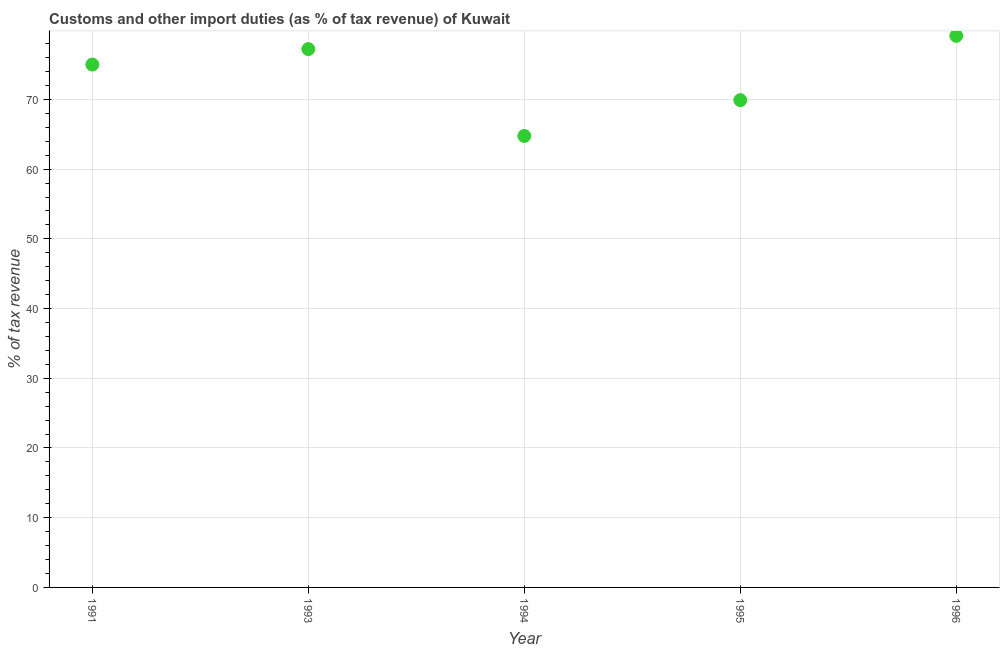What is the customs and other import duties in 1995?
Offer a terse response. 69.89. Across all years, what is the maximum customs and other import duties?
Your answer should be compact. 79.12. Across all years, what is the minimum customs and other import duties?
Ensure brevity in your answer.  64.76. What is the sum of the customs and other import duties?
Your response must be concise. 365.99. What is the difference between the customs and other import duties in 1991 and 1995?
Ensure brevity in your answer.  5.11. What is the average customs and other import duties per year?
Your answer should be compact. 73.2. What is the ratio of the customs and other import duties in 1993 to that in 1994?
Offer a terse response. 1.19. Is the customs and other import duties in 1993 less than that in 1996?
Your response must be concise. Yes. What is the difference between the highest and the second highest customs and other import duties?
Provide a short and direct response. 1.91. Is the sum of the customs and other import duties in 1994 and 1996 greater than the maximum customs and other import duties across all years?
Keep it short and to the point. Yes. What is the difference between the highest and the lowest customs and other import duties?
Offer a terse response. 14.36. How many dotlines are there?
Your response must be concise. 1. What is the difference between two consecutive major ticks on the Y-axis?
Your response must be concise. 10. What is the title of the graph?
Ensure brevity in your answer.  Customs and other import duties (as % of tax revenue) of Kuwait. What is the label or title of the Y-axis?
Keep it short and to the point. % of tax revenue. What is the % of tax revenue in 1993?
Make the answer very short. 77.22. What is the % of tax revenue in 1994?
Offer a terse response. 64.76. What is the % of tax revenue in 1995?
Give a very brief answer. 69.89. What is the % of tax revenue in 1996?
Your response must be concise. 79.12. What is the difference between the % of tax revenue in 1991 and 1993?
Offer a terse response. -2.22. What is the difference between the % of tax revenue in 1991 and 1994?
Your answer should be compact. 10.24. What is the difference between the % of tax revenue in 1991 and 1995?
Make the answer very short. 5.11. What is the difference between the % of tax revenue in 1991 and 1996?
Ensure brevity in your answer.  -4.12. What is the difference between the % of tax revenue in 1993 and 1994?
Give a very brief answer. 12.45. What is the difference between the % of tax revenue in 1993 and 1995?
Keep it short and to the point. 7.32. What is the difference between the % of tax revenue in 1993 and 1996?
Your response must be concise. -1.91. What is the difference between the % of tax revenue in 1994 and 1995?
Ensure brevity in your answer.  -5.13. What is the difference between the % of tax revenue in 1994 and 1996?
Provide a succinct answer. -14.36. What is the difference between the % of tax revenue in 1995 and 1996?
Provide a short and direct response. -9.23. What is the ratio of the % of tax revenue in 1991 to that in 1994?
Give a very brief answer. 1.16. What is the ratio of the % of tax revenue in 1991 to that in 1995?
Make the answer very short. 1.07. What is the ratio of the % of tax revenue in 1991 to that in 1996?
Your answer should be compact. 0.95. What is the ratio of the % of tax revenue in 1993 to that in 1994?
Your answer should be compact. 1.19. What is the ratio of the % of tax revenue in 1993 to that in 1995?
Your response must be concise. 1.1. What is the ratio of the % of tax revenue in 1993 to that in 1996?
Provide a short and direct response. 0.98. What is the ratio of the % of tax revenue in 1994 to that in 1995?
Provide a short and direct response. 0.93. What is the ratio of the % of tax revenue in 1994 to that in 1996?
Give a very brief answer. 0.82. What is the ratio of the % of tax revenue in 1995 to that in 1996?
Give a very brief answer. 0.88. 